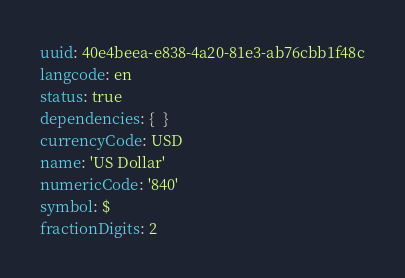<code> <loc_0><loc_0><loc_500><loc_500><_YAML_>uuid: 40e4beea-e838-4a20-81e3-ab76cbb1f48c
langcode: en
status: true
dependencies: {  }
currencyCode: USD
name: 'US Dollar'
numericCode: '840'
symbol: $
fractionDigits: 2
</code> 